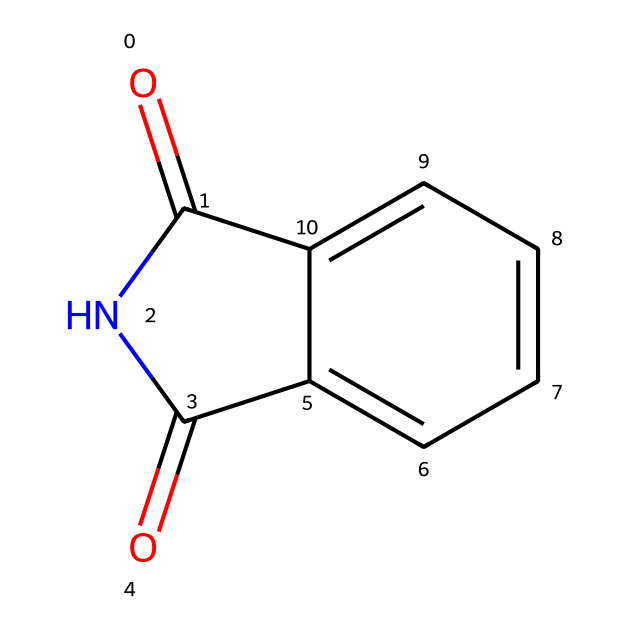What is the molecular formula of phthalimide? To derive the molecular formula, we need to count the number of each type of atom represented in the SMILES structure. There are 8 carbon atoms (C), 5 hydrogen atoms (H), 2 nitrogen atoms (N), and 2 oxygen atoms (O), leading to the formula C8H5N2O2.
Answer: C8H5N2O2 How many rings are present in phthalimide? Observing the structure, there are two interconnected cyclical structures visible. The presence of one six-membered aromatic ring and a five-membered imide ring indicates that there are two rings in total.
Answer: 2 What type of functional groups are present in phthalimide? The primary functional groups identifiable in the structure include an imide group (characterized by the -C(=O)N-) and a carbonyl group (C=O) seen in the imide structure. Therefore, the functional groups are an imide and a carbonyl.
Answer: imide, carbonyl What is the hybridization of the nitrogen atoms in phthalimide? Examining the structure, the nitrogen atoms in phthalimide are involved in sigma bonds with both carbon atoms and the carbonyl oxygen. Given this bonding arrangement, the nitrogen atoms are sp2 hybridized, which allows for planar geometry.
Answer: sp2 How many double bonds are in the structure of phthalimide? In the chemical structure, the presence of the carbonyl (C=O) groups and the double bond connecting the imide to the aromatic carbon implies that there are two double bonds.
Answer: 2 What characteristic feature distinguishes imides from amides in the structure of phthalimide? The key distinction is that imides exhibit an anhydride-like structure where two carbonyl groups are directly connected to a nitrogen atom, as seen in phthalimide. In contrast, amides show a single carbonyl group connected to a nitrogen.
Answer: two carbonyl groups 